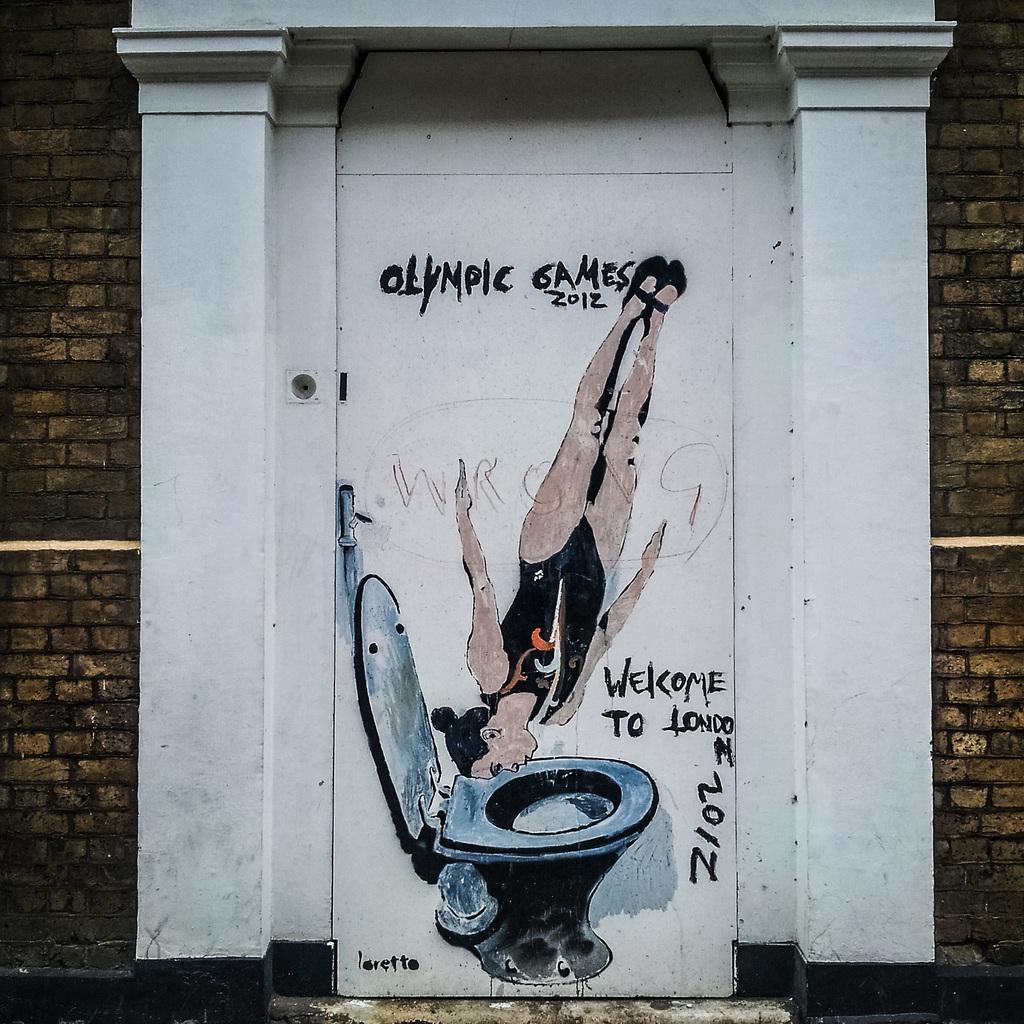What year was this painted?
Provide a short and direct response. 2012. What year were the olympic games being mocked in this painting?
Your answer should be very brief. 2012. 